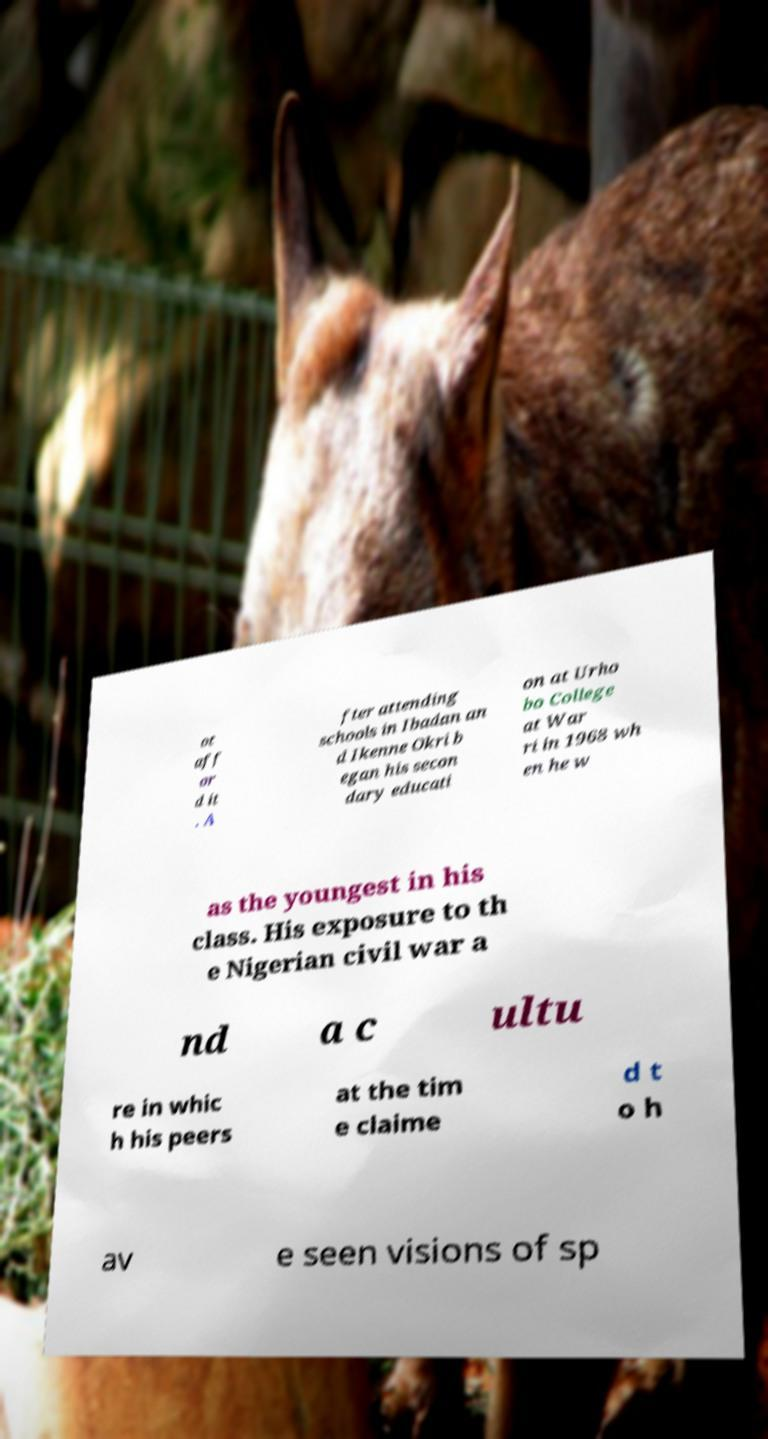Please read and relay the text visible in this image. What does it say? ot aff or d it . A fter attending schools in Ibadan an d Ikenne Okri b egan his secon dary educati on at Urho bo College at War ri in 1968 wh en he w as the youngest in his class. His exposure to th e Nigerian civil war a nd a c ultu re in whic h his peers at the tim e claime d t o h av e seen visions of sp 